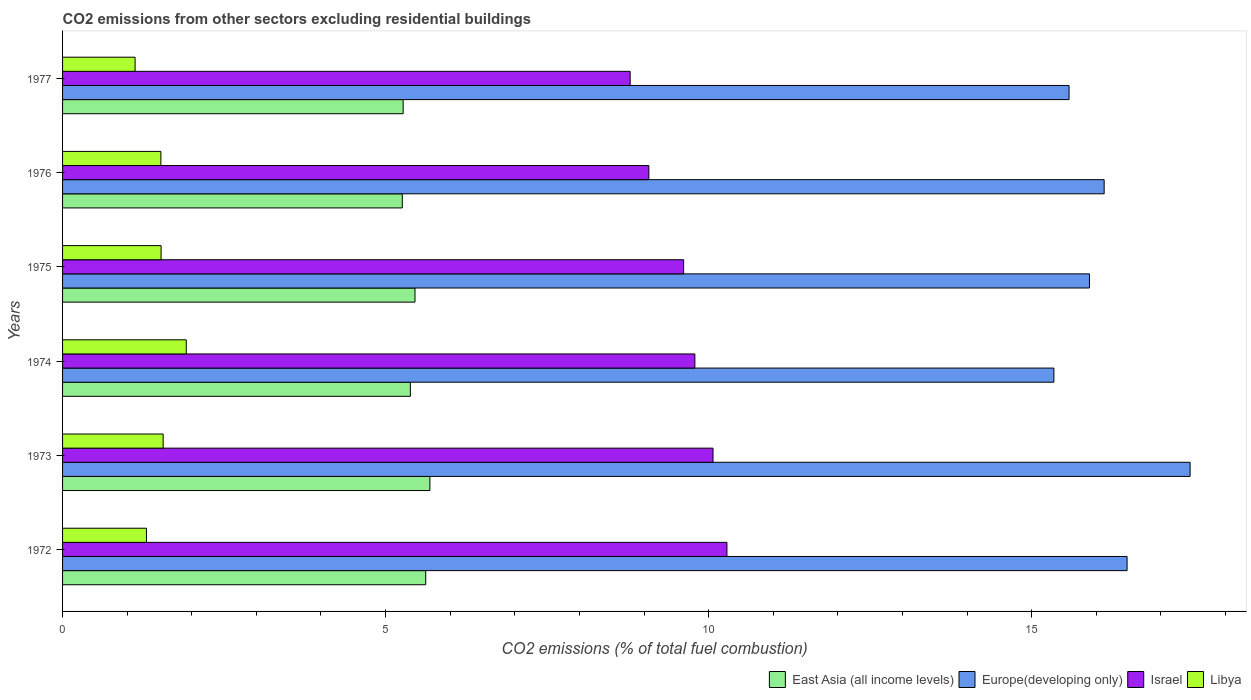Are the number of bars per tick equal to the number of legend labels?
Provide a succinct answer. Yes. In how many cases, is the number of bars for a given year not equal to the number of legend labels?
Ensure brevity in your answer.  0. What is the total CO2 emitted in Libya in 1976?
Your answer should be very brief. 1.52. Across all years, what is the maximum total CO2 emitted in Israel?
Offer a terse response. 10.28. Across all years, what is the minimum total CO2 emitted in East Asia (all income levels)?
Ensure brevity in your answer.  5.26. What is the total total CO2 emitted in Europe(developing only) in the graph?
Offer a very short reply. 96.87. What is the difference between the total CO2 emitted in Europe(developing only) in 1973 and that in 1974?
Make the answer very short. 2.11. What is the difference between the total CO2 emitted in Israel in 1975 and the total CO2 emitted in East Asia (all income levels) in 1976?
Provide a short and direct response. 4.35. What is the average total CO2 emitted in East Asia (all income levels) per year?
Make the answer very short. 5.45. In the year 1977, what is the difference between the total CO2 emitted in Europe(developing only) and total CO2 emitted in Israel?
Offer a very short reply. 6.79. In how many years, is the total CO2 emitted in Israel greater than 1 ?
Your answer should be very brief. 6. What is the ratio of the total CO2 emitted in Israel in 1972 to that in 1975?
Provide a short and direct response. 1.07. Is the total CO2 emitted in Israel in 1975 less than that in 1976?
Give a very brief answer. No. What is the difference between the highest and the second highest total CO2 emitted in Libya?
Your answer should be compact. 0.36. What is the difference between the highest and the lowest total CO2 emitted in Israel?
Keep it short and to the point. 1.5. In how many years, is the total CO2 emitted in Libya greater than the average total CO2 emitted in Libya taken over all years?
Make the answer very short. 4. Is the sum of the total CO2 emitted in Europe(developing only) in 1972 and 1975 greater than the maximum total CO2 emitted in Israel across all years?
Your response must be concise. Yes. What does the 1st bar from the top in 1977 represents?
Offer a very short reply. Libya. What does the 4th bar from the bottom in 1974 represents?
Your answer should be compact. Libya. Is it the case that in every year, the sum of the total CO2 emitted in Libya and total CO2 emitted in East Asia (all income levels) is greater than the total CO2 emitted in Israel?
Provide a short and direct response. No. How many bars are there?
Your answer should be compact. 24. Are the values on the major ticks of X-axis written in scientific E-notation?
Offer a very short reply. No. Does the graph contain any zero values?
Make the answer very short. No. Does the graph contain grids?
Keep it short and to the point. No. How many legend labels are there?
Keep it short and to the point. 4. What is the title of the graph?
Your answer should be compact. CO2 emissions from other sectors excluding residential buildings. Does "Morocco" appear as one of the legend labels in the graph?
Your response must be concise. No. What is the label or title of the X-axis?
Your answer should be compact. CO2 emissions (% of total fuel combustion). What is the label or title of the Y-axis?
Give a very brief answer. Years. What is the CO2 emissions (% of total fuel combustion) of East Asia (all income levels) in 1972?
Your answer should be very brief. 5.62. What is the CO2 emissions (% of total fuel combustion) of Europe(developing only) in 1972?
Offer a very short reply. 16.48. What is the CO2 emissions (% of total fuel combustion) in Israel in 1972?
Give a very brief answer. 10.28. What is the CO2 emissions (% of total fuel combustion) in Libya in 1972?
Offer a terse response. 1.3. What is the CO2 emissions (% of total fuel combustion) in East Asia (all income levels) in 1973?
Your answer should be compact. 5.69. What is the CO2 emissions (% of total fuel combustion) of Europe(developing only) in 1973?
Offer a very short reply. 17.45. What is the CO2 emissions (% of total fuel combustion) of Israel in 1973?
Offer a terse response. 10.07. What is the CO2 emissions (% of total fuel combustion) in Libya in 1973?
Provide a succinct answer. 1.56. What is the CO2 emissions (% of total fuel combustion) of East Asia (all income levels) in 1974?
Your answer should be very brief. 5.38. What is the CO2 emissions (% of total fuel combustion) in Europe(developing only) in 1974?
Offer a terse response. 15.34. What is the CO2 emissions (% of total fuel combustion) in Israel in 1974?
Offer a terse response. 9.79. What is the CO2 emissions (% of total fuel combustion) in Libya in 1974?
Offer a terse response. 1.91. What is the CO2 emissions (% of total fuel combustion) in East Asia (all income levels) in 1975?
Keep it short and to the point. 5.45. What is the CO2 emissions (% of total fuel combustion) in Europe(developing only) in 1975?
Offer a very short reply. 15.89. What is the CO2 emissions (% of total fuel combustion) in Israel in 1975?
Provide a succinct answer. 9.61. What is the CO2 emissions (% of total fuel combustion) in Libya in 1975?
Provide a succinct answer. 1.53. What is the CO2 emissions (% of total fuel combustion) in East Asia (all income levels) in 1976?
Offer a terse response. 5.26. What is the CO2 emissions (% of total fuel combustion) of Europe(developing only) in 1976?
Your response must be concise. 16.12. What is the CO2 emissions (% of total fuel combustion) of Israel in 1976?
Give a very brief answer. 9.07. What is the CO2 emissions (% of total fuel combustion) in Libya in 1976?
Your answer should be very brief. 1.52. What is the CO2 emissions (% of total fuel combustion) of East Asia (all income levels) in 1977?
Your response must be concise. 5.27. What is the CO2 emissions (% of total fuel combustion) of Europe(developing only) in 1977?
Give a very brief answer. 15.58. What is the CO2 emissions (% of total fuel combustion) of Israel in 1977?
Provide a succinct answer. 8.79. What is the CO2 emissions (% of total fuel combustion) of Libya in 1977?
Your answer should be compact. 1.12. Across all years, what is the maximum CO2 emissions (% of total fuel combustion) in East Asia (all income levels)?
Offer a terse response. 5.69. Across all years, what is the maximum CO2 emissions (% of total fuel combustion) of Europe(developing only)?
Keep it short and to the point. 17.45. Across all years, what is the maximum CO2 emissions (% of total fuel combustion) of Israel?
Make the answer very short. 10.28. Across all years, what is the maximum CO2 emissions (% of total fuel combustion) in Libya?
Offer a terse response. 1.91. Across all years, what is the minimum CO2 emissions (% of total fuel combustion) in East Asia (all income levels)?
Provide a succinct answer. 5.26. Across all years, what is the minimum CO2 emissions (% of total fuel combustion) of Europe(developing only)?
Your answer should be compact. 15.34. Across all years, what is the minimum CO2 emissions (% of total fuel combustion) of Israel?
Your response must be concise. 8.79. Across all years, what is the minimum CO2 emissions (% of total fuel combustion) of Libya?
Provide a succinct answer. 1.12. What is the total CO2 emissions (% of total fuel combustion) in East Asia (all income levels) in the graph?
Make the answer very short. 32.68. What is the total CO2 emissions (% of total fuel combustion) of Europe(developing only) in the graph?
Offer a terse response. 96.87. What is the total CO2 emissions (% of total fuel combustion) in Israel in the graph?
Keep it short and to the point. 57.61. What is the total CO2 emissions (% of total fuel combustion) of Libya in the graph?
Give a very brief answer. 8.94. What is the difference between the CO2 emissions (% of total fuel combustion) of East Asia (all income levels) in 1972 and that in 1973?
Provide a succinct answer. -0.06. What is the difference between the CO2 emissions (% of total fuel combustion) of Europe(developing only) in 1972 and that in 1973?
Offer a terse response. -0.98. What is the difference between the CO2 emissions (% of total fuel combustion) of Israel in 1972 and that in 1973?
Make the answer very short. 0.22. What is the difference between the CO2 emissions (% of total fuel combustion) of Libya in 1972 and that in 1973?
Provide a succinct answer. -0.26. What is the difference between the CO2 emissions (% of total fuel combustion) in East Asia (all income levels) in 1972 and that in 1974?
Provide a succinct answer. 0.24. What is the difference between the CO2 emissions (% of total fuel combustion) of Europe(developing only) in 1972 and that in 1974?
Provide a succinct answer. 1.13. What is the difference between the CO2 emissions (% of total fuel combustion) of Israel in 1972 and that in 1974?
Your response must be concise. 0.5. What is the difference between the CO2 emissions (% of total fuel combustion) of Libya in 1972 and that in 1974?
Ensure brevity in your answer.  -0.62. What is the difference between the CO2 emissions (% of total fuel combustion) in East Asia (all income levels) in 1972 and that in 1975?
Offer a very short reply. 0.17. What is the difference between the CO2 emissions (% of total fuel combustion) of Europe(developing only) in 1972 and that in 1975?
Your response must be concise. 0.58. What is the difference between the CO2 emissions (% of total fuel combustion) in Israel in 1972 and that in 1975?
Offer a very short reply. 0.67. What is the difference between the CO2 emissions (% of total fuel combustion) in Libya in 1972 and that in 1975?
Give a very brief answer. -0.23. What is the difference between the CO2 emissions (% of total fuel combustion) in East Asia (all income levels) in 1972 and that in 1976?
Keep it short and to the point. 0.36. What is the difference between the CO2 emissions (% of total fuel combustion) in Europe(developing only) in 1972 and that in 1976?
Provide a short and direct response. 0.35. What is the difference between the CO2 emissions (% of total fuel combustion) in Israel in 1972 and that in 1976?
Your response must be concise. 1.21. What is the difference between the CO2 emissions (% of total fuel combustion) in Libya in 1972 and that in 1976?
Your answer should be compact. -0.22. What is the difference between the CO2 emissions (% of total fuel combustion) in East Asia (all income levels) in 1972 and that in 1977?
Your response must be concise. 0.35. What is the difference between the CO2 emissions (% of total fuel combustion) of Europe(developing only) in 1972 and that in 1977?
Give a very brief answer. 0.9. What is the difference between the CO2 emissions (% of total fuel combustion) of Israel in 1972 and that in 1977?
Make the answer very short. 1.5. What is the difference between the CO2 emissions (% of total fuel combustion) in Libya in 1972 and that in 1977?
Your answer should be very brief. 0.18. What is the difference between the CO2 emissions (% of total fuel combustion) of East Asia (all income levels) in 1973 and that in 1974?
Give a very brief answer. 0.3. What is the difference between the CO2 emissions (% of total fuel combustion) in Europe(developing only) in 1973 and that in 1974?
Provide a short and direct response. 2.11. What is the difference between the CO2 emissions (% of total fuel combustion) of Israel in 1973 and that in 1974?
Offer a terse response. 0.28. What is the difference between the CO2 emissions (% of total fuel combustion) of Libya in 1973 and that in 1974?
Keep it short and to the point. -0.36. What is the difference between the CO2 emissions (% of total fuel combustion) of East Asia (all income levels) in 1973 and that in 1975?
Provide a short and direct response. 0.23. What is the difference between the CO2 emissions (% of total fuel combustion) of Europe(developing only) in 1973 and that in 1975?
Your response must be concise. 1.56. What is the difference between the CO2 emissions (% of total fuel combustion) in Israel in 1973 and that in 1975?
Your answer should be compact. 0.45. What is the difference between the CO2 emissions (% of total fuel combustion) in Libya in 1973 and that in 1975?
Provide a short and direct response. 0.03. What is the difference between the CO2 emissions (% of total fuel combustion) in East Asia (all income levels) in 1973 and that in 1976?
Keep it short and to the point. 0.43. What is the difference between the CO2 emissions (% of total fuel combustion) of Europe(developing only) in 1973 and that in 1976?
Make the answer very short. 1.33. What is the difference between the CO2 emissions (% of total fuel combustion) in Israel in 1973 and that in 1976?
Your response must be concise. 0.99. What is the difference between the CO2 emissions (% of total fuel combustion) in Libya in 1973 and that in 1976?
Your answer should be compact. 0.04. What is the difference between the CO2 emissions (% of total fuel combustion) in East Asia (all income levels) in 1973 and that in 1977?
Provide a succinct answer. 0.41. What is the difference between the CO2 emissions (% of total fuel combustion) of Europe(developing only) in 1973 and that in 1977?
Give a very brief answer. 1.87. What is the difference between the CO2 emissions (% of total fuel combustion) in Israel in 1973 and that in 1977?
Provide a short and direct response. 1.28. What is the difference between the CO2 emissions (% of total fuel combustion) in Libya in 1973 and that in 1977?
Offer a very short reply. 0.43. What is the difference between the CO2 emissions (% of total fuel combustion) in East Asia (all income levels) in 1974 and that in 1975?
Your answer should be very brief. -0.07. What is the difference between the CO2 emissions (% of total fuel combustion) of Europe(developing only) in 1974 and that in 1975?
Your response must be concise. -0.55. What is the difference between the CO2 emissions (% of total fuel combustion) of Israel in 1974 and that in 1975?
Provide a succinct answer. 0.17. What is the difference between the CO2 emissions (% of total fuel combustion) of Libya in 1974 and that in 1975?
Your answer should be very brief. 0.39. What is the difference between the CO2 emissions (% of total fuel combustion) in East Asia (all income levels) in 1974 and that in 1976?
Offer a terse response. 0.12. What is the difference between the CO2 emissions (% of total fuel combustion) of Europe(developing only) in 1974 and that in 1976?
Keep it short and to the point. -0.78. What is the difference between the CO2 emissions (% of total fuel combustion) in Israel in 1974 and that in 1976?
Keep it short and to the point. 0.71. What is the difference between the CO2 emissions (% of total fuel combustion) of Libya in 1974 and that in 1976?
Your answer should be very brief. 0.39. What is the difference between the CO2 emissions (% of total fuel combustion) of East Asia (all income levels) in 1974 and that in 1977?
Your response must be concise. 0.11. What is the difference between the CO2 emissions (% of total fuel combustion) of Europe(developing only) in 1974 and that in 1977?
Your answer should be compact. -0.23. What is the difference between the CO2 emissions (% of total fuel combustion) of Israel in 1974 and that in 1977?
Your answer should be very brief. 1. What is the difference between the CO2 emissions (% of total fuel combustion) of Libya in 1974 and that in 1977?
Offer a terse response. 0.79. What is the difference between the CO2 emissions (% of total fuel combustion) of East Asia (all income levels) in 1975 and that in 1976?
Keep it short and to the point. 0.2. What is the difference between the CO2 emissions (% of total fuel combustion) of Europe(developing only) in 1975 and that in 1976?
Your response must be concise. -0.23. What is the difference between the CO2 emissions (% of total fuel combustion) in Israel in 1975 and that in 1976?
Provide a succinct answer. 0.54. What is the difference between the CO2 emissions (% of total fuel combustion) of Libya in 1975 and that in 1976?
Make the answer very short. 0. What is the difference between the CO2 emissions (% of total fuel combustion) in East Asia (all income levels) in 1975 and that in 1977?
Provide a succinct answer. 0.18. What is the difference between the CO2 emissions (% of total fuel combustion) of Europe(developing only) in 1975 and that in 1977?
Ensure brevity in your answer.  0.32. What is the difference between the CO2 emissions (% of total fuel combustion) in Israel in 1975 and that in 1977?
Offer a very short reply. 0.83. What is the difference between the CO2 emissions (% of total fuel combustion) of Libya in 1975 and that in 1977?
Offer a terse response. 0.4. What is the difference between the CO2 emissions (% of total fuel combustion) of East Asia (all income levels) in 1976 and that in 1977?
Keep it short and to the point. -0.01. What is the difference between the CO2 emissions (% of total fuel combustion) in Europe(developing only) in 1976 and that in 1977?
Your answer should be very brief. 0.54. What is the difference between the CO2 emissions (% of total fuel combustion) in Israel in 1976 and that in 1977?
Your response must be concise. 0.29. What is the difference between the CO2 emissions (% of total fuel combustion) in Libya in 1976 and that in 1977?
Offer a terse response. 0.4. What is the difference between the CO2 emissions (% of total fuel combustion) of East Asia (all income levels) in 1972 and the CO2 emissions (% of total fuel combustion) of Europe(developing only) in 1973?
Your answer should be very brief. -11.83. What is the difference between the CO2 emissions (% of total fuel combustion) in East Asia (all income levels) in 1972 and the CO2 emissions (% of total fuel combustion) in Israel in 1973?
Keep it short and to the point. -4.45. What is the difference between the CO2 emissions (% of total fuel combustion) in East Asia (all income levels) in 1972 and the CO2 emissions (% of total fuel combustion) in Libya in 1973?
Make the answer very short. 4.06. What is the difference between the CO2 emissions (% of total fuel combustion) in Europe(developing only) in 1972 and the CO2 emissions (% of total fuel combustion) in Israel in 1973?
Your answer should be very brief. 6.41. What is the difference between the CO2 emissions (% of total fuel combustion) of Europe(developing only) in 1972 and the CO2 emissions (% of total fuel combustion) of Libya in 1973?
Offer a very short reply. 14.92. What is the difference between the CO2 emissions (% of total fuel combustion) in Israel in 1972 and the CO2 emissions (% of total fuel combustion) in Libya in 1973?
Keep it short and to the point. 8.73. What is the difference between the CO2 emissions (% of total fuel combustion) in East Asia (all income levels) in 1972 and the CO2 emissions (% of total fuel combustion) in Europe(developing only) in 1974?
Offer a terse response. -9.72. What is the difference between the CO2 emissions (% of total fuel combustion) in East Asia (all income levels) in 1972 and the CO2 emissions (% of total fuel combustion) in Israel in 1974?
Your response must be concise. -4.17. What is the difference between the CO2 emissions (% of total fuel combustion) of East Asia (all income levels) in 1972 and the CO2 emissions (% of total fuel combustion) of Libya in 1974?
Make the answer very short. 3.71. What is the difference between the CO2 emissions (% of total fuel combustion) of Europe(developing only) in 1972 and the CO2 emissions (% of total fuel combustion) of Israel in 1974?
Make the answer very short. 6.69. What is the difference between the CO2 emissions (% of total fuel combustion) of Europe(developing only) in 1972 and the CO2 emissions (% of total fuel combustion) of Libya in 1974?
Give a very brief answer. 14.56. What is the difference between the CO2 emissions (% of total fuel combustion) of Israel in 1972 and the CO2 emissions (% of total fuel combustion) of Libya in 1974?
Make the answer very short. 8.37. What is the difference between the CO2 emissions (% of total fuel combustion) in East Asia (all income levels) in 1972 and the CO2 emissions (% of total fuel combustion) in Europe(developing only) in 1975?
Your answer should be very brief. -10.27. What is the difference between the CO2 emissions (% of total fuel combustion) of East Asia (all income levels) in 1972 and the CO2 emissions (% of total fuel combustion) of Israel in 1975?
Your answer should be very brief. -3.99. What is the difference between the CO2 emissions (% of total fuel combustion) in East Asia (all income levels) in 1972 and the CO2 emissions (% of total fuel combustion) in Libya in 1975?
Offer a very short reply. 4.1. What is the difference between the CO2 emissions (% of total fuel combustion) in Europe(developing only) in 1972 and the CO2 emissions (% of total fuel combustion) in Israel in 1975?
Offer a terse response. 6.86. What is the difference between the CO2 emissions (% of total fuel combustion) of Europe(developing only) in 1972 and the CO2 emissions (% of total fuel combustion) of Libya in 1975?
Offer a terse response. 14.95. What is the difference between the CO2 emissions (% of total fuel combustion) in Israel in 1972 and the CO2 emissions (% of total fuel combustion) in Libya in 1975?
Offer a terse response. 8.76. What is the difference between the CO2 emissions (% of total fuel combustion) in East Asia (all income levels) in 1972 and the CO2 emissions (% of total fuel combustion) in Europe(developing only) in 1976?
Your answer should be very brief. -10.5. What is the difference between the CO2 emissions (% of total fuel combustion) in East Asia (all income levels) in 1972 and the CO2 emissions (% of total fuel combustion) in Israel in 1976?
Ensure brevity in your answer.  -3.45. What is the difference between the CO2 emissions (% of total fuel combustion) in East Asia (all income levels) in 1972 and the CO2 emissions (% of total fuel combustion) in Libya in 1976?
Make the answer very short. 4.1. What is the difference between the CO2 emissions (% of total fuel combustion) in Europe(developing only) in 1972 and the CO2 emissions (% of total fuel combustion) in Israel in 1976?
Ensure brevity in your answer.  7.4. What is the difference between the CO2 emissions (% of total fuel combustion) of Europe(developing only) in 1972 and the CO2 emissions (% of total fuel combustion) of Libya in 1976?
Your response must be concise. 14.96. What is the difference between the CO2 emissions (% of total fuel combustion) of Israel in 1972 and the CO2 emissions (% of total fuel combustion) of Libya in 1976?
Offer a terse response. 8.76. What is the difference between the CO2 emissions (% of total fuel combustion) in East Asia (all income levels) in 1972 and the CO2 emissions (% of total fuel combustion) in Europe(developing only) in 1977?
Ensure brevity in your answer.  -9.96. What is the difference between the CO2 emissions (% of total fuel combustion) in East Asia (all income levels) in 1972 and the CO2 emissions (% of total fuel combustion) in Israel in 1977?
Give a very brief answer. -3.16. What is the difference between the CO2 emissions (% of total fuel combustion) of East Asia (all income levels) in 1972 and the CO2 emissions (% of total fuel combustion) of Libya in 1977?
Give a very brief answer. 4.5. What is the difference between the CO2 emissions (% of total fuel combustion) of Europe(developing only) in 1972 and the CO2 emissions (% of total fuel combustion) of Israel in 1977?
Offer a very short reply. 7.69. What is the difference between the CO2 emissions (% of total fuel combustion) of Europe(developing only) in 1972 and the CO2 emissions (% of total fuel combustion) of Libya in 1977?
Your answer should be very brief. 15.35. What is the difference between the CO2 emissions (% of total fuel combustion) in Israel in 1972 and the CO2 emissions (% of total fuel combustion) in Libya in 1977?
Your answer should be very brief. 9.16. What is the difference between the CO2 emissions (% of total fuel combustion) in East Asia (all income levels) in 1973 and the CO2 emissions (% of total fuel combustion) in Europe(developing only) in 1974?
Offer a very short reply. -9.66. What is the difference between the CO2 emissions (% of total fuel combustion) of East Asia (all income levels) in 1973 and the CO2 emissions (% of total fuel combustion) of Israel in 1974?
Ensure brevity in your answer.  -4.1. What is the difference between the CO2 emissions (% of total fuel combustion) in East Asia (all income levels) in 1973 and the CO2 emissions (% of total fuel combustion) in Libya in 1974?
Offer a very short reply. 3.77. What is the difference between the CO2 emissions (% of total fuel combustion) of Europe(developing only) in 1973 and the CO2 emissions (% of total fuel combustion) of Israel in 1974?
Give a very brief answer. 7.67. What is the difference between the CO2 emissions (% of total fuel combustion) in Europe(developing only) in 1973 and the CO2 emissions (% of total fuel combustion) in Libya in 1974?
Keep it short and to the point. 15.54. What is the difference between the CO2 emissions (% of total fuel combustion) in Israel in 1973 and the CO2 emissions (% of total fuel combustion) in Libya in 1974?
Your answer should be very brief. 8.15. What is the difference between the CO2 emissions (% of total fuel combustion) of East Asia (all income levels) in 1973 and the CO2 emissions (% of total fuel combustion) of Europe(developing only) in 1975?
Provide a succinct answer. -10.21. What is the difference between the CO2 emissions (% of total fuel combustion) of East Asia (all income levels) in 1973 and the CO2 emissions (% of total fuel combustion) of Israel in 1975?
Make the answer very short. -3.93. What is the difference between the CO2 emissions (% of total fuel combustion) in East Asia (all income levels) in 1973 and the CO2 emissions (% of total fuel combustion) in Libya in 1975?
Your answer should be compact. 4.16. What is the difference between the CO2 emissions (% of total fuel combustion) in Europe(developing only) in 1973 and the CO2 emissions (% of total fuel combustion) in Israel in 1975?
Your response must be concise. 7.84. What is the difference between the CO2 emissions (% of total fuel combustion) in Europe(developing only) in 1973 and the CO2 emissions (% of total fuel combustion) in Libya in 1975?
Ensure brevity in your answer.  15.93. What is the difference between the CO2 emissions (% of total fuel combustion) in Israel in 1973 and the CO2 emissions (% of total fuel combustion) in Libya in 1975?
Your answer should be compact. 8.54. What is the difference between the CO2 emissions (% of total fuel combustion) of East Asia (all income levels) in 1973 and the CO2 emissions (% of total fuel combustion) of Europe(developing only) in 1976?
Ensure brevity in your answer.  -10.44. What is the difference between the CO2 emissions (% of total fuel combustion) of East Asia (all income levels) in 1973 and the CO2 emissions (% of total fuel combustion) of Israel in 1976?
Give a very brief answer. -3.39. What is the difference between the CO2 emissions (% of total fuel combustion) of East Asia (all income levels) in 1973 and the CO2 emissions (% of total fuel combustion) of Libya in 1976?
Offer a terse response. 4.16. What is the difference between the CO2 emissions (% of total fuel combustion) in Europe(developing only) in 1973 and the CO2 emissions (% of total fuel combustion) in Israel in 1976?
Give a very brief answer. 8.38. What is the difference between the CO2 emissions (% of total fuel combustion) of Europe(developing only) in 1973 and the CO2 emissions (% of total fuel combustion) of Libya in 1976?
Keep it short and to the point. 15.93. What is the difference between the CO2 emissions (% of total fuel combustion) in Israel in 1973 and the CO2 emissions (% of total fuel combustion) in Libya in 1976?
Your answer should be compact. 8.55. What is the difference between the CO2 emissions (% of total fuel combustion) in East Asia (all income levels) in 1973 and the CO2 emissions (% of total fuel combustion) in Europe(developing only) in 1977?
Your answer should be compact. -9.89. What is the difference between the CO2 emissions (% of total fuel combustion) of East Asia (all income levels) in 1973 and the CO2 emissions (% of total fuel combustion) of Israel in 1977?
Your answer should be compact. -3.1. What is the difference between the CO2 emissions (% of total fuel combustion) of East Asia (all income levels) in 1973 and the CO2 emissions (% of total fuel combustion) of Libya in 1977?
Keep it short and to the point. 4.56. What is the difference between the CO2 emissions (% of total fuel combustion) of Europe(developing only) in 1973 and the CO2 emissions (% of total fuel combustion) of Israel in 1977?
Give a very brief answer. 8.67. What is the difference between the CO2 emissions (% of total fuel combustion) in Europe(developing only) in 1973 and the CO2 emissions (% of total fuel combustion) in Libya in 1977?
Offer a very short reply. 16.33. What is the difference between the CO2 emissions (% of total fuel combustion) in Israel in 1973 and the CO2 emissions (% of total fuel combustion) in Libya in 1977?
Your answer should be very brief. 8.95. What is the difference between the CO2 emissions (% of total fuel combustion) of East Asia (all income levels) in 1974 and the CO2 emissions (% of total fuel combustion) of Europe(developing only) in 1975?
Provide a succinct answer. -10.51. What is the difference between the CO2 emissions (% of total fuel combustion) of East Asia (all income levels) in 1974 and the CO2 emissions (% of total fuel combustion) of Israel in 1975?
Give a very brief answer. -4.23. What is the difference between the CO2 emissions (% of total fuel combustion) in East Asia (all income levels) in 1974 and the CO2 emissions (% of total fuel combustion) in Libya in 1975?
Give a very brief answer. 3.86. What is the difference between the CO2 emissions (% of total fuel combustion) of Europe(developing only) in 1974 and the CO2 emissions (% of total fuel combustion) of Israel in 1975?
Give a very brief answer. 5.73. What is the difference between the CO2 emissions (% of total fuel combustion) of Europe(developing only) in 1974 and the CO2 emissions (% of total fuel combustion) of Libya in 1975?
Your answer should be very brief. 13.82. What is the difference between the CO2 emissions (% of total fuel combustion) of Israel in 1974 and the CO2 emissions (% of total fuel combustion) of Libya in 1975?
Your answer should be very brief. 8.26. What is the difference between the CO2 emissions (% of total fuel combustion) of East Asia (all income levels) in 1974 and the CO2 emissions (% of total fuel combustion) of Europe(developing only) in 1976?
Your response must be concise. -10.74. What is the difference between the CO2 emissions (% of total fuel combustion) in East Asia (all income levels) in 1974 and the CO2 emissions (% of total fuel combustion) in Israel in 1976?
Give a very brief answer. -3.69. What is the difference between the CO2 emissions (% of total fuel combustion) of East Asia (all income levels) in 1974 and the CO2 emissions (% of total fuel combustion) of Libya in 1976?
Provide a succinct answer. 3.86. What is the difference between the CO2 emissions (% of total fuel combustion) in Europe(developing only) in 1974 and the CO2 emissions (% of total fuel combustion) in Israel in 1976?
Provide a short and direct response. 6.27. What is the difference between the CO2 emissions (% of total fuel combustion) in Europe(developing only) in 1974 and the CO2 emissions (% of total fuel combustion) in Libya in 1976?
Ensure brevity in your answer.  13.82. What is the difference between the CO2 emissions (% of total fuel combustion) of Israel in 1974 and the CO2 emissions (% of total fuel combustion) of Libya in 1976?
Provide a succinct answer. 8.27. What is the difference between the CO2 emissions (% of total fuel combustion) in East Asia (all income levels) in 1974 and the CO2 emissions (% of total fuel combustion) in Europe(developing only) in 1977?
Your response must be concise. -10.2. What is the difference between the CO2 emissions (% of total fuel combustion) of East Asia (all income levels) in 1974 and the CO2 emissions (% of total fuel combustion) of Israel in 1977?
Provide a succinct answer. -3.4. What is the difference between the CO2 emissions (% of total fuel combustion) in East Asia (all income levels) in 1974 and the CO2 emissions (% of total fuel combustion) in Libya in 1977?
Ensure brevity in your answer.  4.26. What is the difference between the CO2 emissions (% of total fuel combustion) in Europe(developing only) in 1974 and the CO2 emissions (% of total fuel combustion) in Israel in 1977?
Offer a terse response. 6.56. What is the difference between the CO2 emissions (% of total fuel combustion) in Europe(developing only) in 1974 and the CO2 emissions (% of total fuel combustion) in Libya in 1977?
Provide a short and direct response. 14.22. What is the difference between the CO2 emissions (% of total fuel combustion) of Israel in 1974 and the CO2 emissions (% of total fuel combustion) of Libya in 1977?
Offer a very short reply. 8.66. What is the difference between the CO2 emissions (% of total fuel combustion) in East Asia (all income levels) in 1975 and the CO2 emissions (% of total fuel combustion) in Europe(developing only) in 1976?
Ensure brevity in your answer.  -10.67. What is the difference between the CO2 emissions (% of total fuel combustion) of East Asia (all income levels) in 1975 and the CO2 emissions (% of total fuel combustion) of Israel in 1976?
Your answer should be compact. -3.62. What is the difference between the CO2 emissions (% of total fuel combustion) of East Asia (all income levels) in 1975 and the CO2 emissions (% of total fuel combustion) of Libya in 1976?
Keep it short and to the point. 3.93. What is the difference between the CO2 emissions (% of total fuel combustion) of Europe(developing only) in 1975 and the CO2 emissions (% of total fuel combustion) of Israel in 1976?
Your answer should be compact. 6.82. What is the difference between the CO2 emissions (% of total fuel combustion) of Europe(developing only) in 1975 and the CO2 emissions (% of total fuel combustion) of Libya in 1976?
Provide a succinct answer. 14.37. What is the difference between the CO2 emissions (% of total fuel combustion) of Israel in 1975 and the CO2 emissions (% of total fuel combustion) of Libya in 1976?
Ensure brevity in your answer.  8.09. What is the difference between the CO2 emissions (% of total fuel combustion) in East Asia (all income levels) in 1975 and the CO2 emissions (% of total fuel combustion) in Europe(developing only) in 1977?
Offer a terse response. -10.12. What is the difference between the CO2 emissions (% of total fuel combustion) of East Asia (all income levels) in 1975 and the CO2 emissions (% of total fuel combustion) of Israel in 1977?
Your answer should be compact. -3.33. What is the difference between the CO2 emissions (% of total fuel combustion) of East Asia (all income levels) in 1975 and the CO2 emissions (% of total fuel combustion) of Libya in 1977?
Offer a terse response. 4.33. What is the difference between the CO2 emissions (% of total fuel combustion) in Europe(developing only) in 1975 and the CO2 emissions (% of total fuel combustion) in Israel in 1977?
Your answer should be very brief. 7.11. What is the difference between the CO2 emissions (% of total fuel combustion) in Europe(developing only) in 1975 and the CO2 emissions (% of total fuel combustion) in Libya in 1977?
Give a very brief answer. 14.77. What is the difference between the CO2 emissions (% of total fuel combustion) of Israel in 1975 and the CO2 emissions (% of total fuel combustion) of Libya in 1977?
Your answer should be compact. 8.49. What is the difference between the CO2 emissions (% of total fuel combustion) in East Asia (all income levels) in 1976 and the CO2 emissions (% of total fuel combustion) in Europe(developing only) in 1977?
Offer a terse response. -10.32. What is the difference between the CO2 emissions (% of total fuel combustion) of East Asia (all income levels) in 1976 and the CO2 emissions (% of total fuel combustion) of Israel in 1977?
Provide a short and direct response. -3.53. What is the difference between the CO2 emissions (% of total fuel combustion) of East Asia (all income levels) in 1976 and the CO2 emissions (% of total fuel combustion) of Libya in 1977?
Your answer should be very brief. 4.14. What is the difference between the CO2 emissions (% of total fuel combustion) in Europe(developing only) in 1976 and the CO2 emissions (% of total fuel combustion) in Israel in 1977?
Provide a succinct answer. 7.34. What is the difference between the CO2 emissions (% of total fuel combustion) of Europe(developing only) in 1976 and the CO2 emissions (% of total fuel combustion) of Libya in 1977?
Provide a short and direct response. 15. What is the difference between the CO2 emissions (% of total fuel combustion) of Israel in 1976 and the CO2 emissions (% of total fuel combustion) of Libya in 1977?
Offer a very short reply. 7.95. What is the average CO2 emissions (% of total fuel combustion) in East Asia (all income levels) per year?
Your response must be concise. 5.45. What is the average CO2 emissions (% of total fuel combustion) in Europe(developing only) per year?
Keep it short and to the point. 16.14. What is the average CO2 emissions (% of total fuel combustion) in Israel per year?
Ensure brevity in your answer.  9.6. What is the average CO2 emissions (% of total fuel combustion) of Libya per year?
Your answer should be compact. 1.49. In the year 1972, what is the difference between the CO2 emissions (% of total fuel combustion) in East Asia (all income levels) and CO2 emissions (% of total fuel combustion) in Europe(developing only)?
Provide a succinct answer. -10.86. In the year 1972, what is the difference between the CO2 emissions (% of total fuel combustion) in East Asia (all income levels) and CO2 emissions (% of total fuel combustion) in Israel?
Your answer should be compact. -4.66. In the year 1972, what is the difference between the CO2 emissions (% of total fuel combustion) of East Asia (all income levels) and CO2 emissions (% of total fuel combustion) of Libya?
Your answer should be very brief. 4.32. In the year 1972, what is the difference between the CO2 emissions (% of total fuel combustion) of Europe(developing only) and CO2 emissions (% of total fuel combustion) of Israel?
Your response must be concise. 6.19. In the year 1972, what is the difference between the CO2 emissions (% of total fuel combustion) of Europe(developing only) and CO2 emissions (% of total fuel combustion) of Libya?
Provide a short and direct response. 15.18. In the year 1972, what is the difference between the CO2 emissions (% of total fuel combustion) of Israel and CO2 emissions (% of total fuel combustion) of Libya?
Ensure brevity in your answer.  8.98. In the year 1973, what is the difference between the CO2 emissions (% of total fuel combustion) of East Asia (all income levels) and CO2 emissions (% of total fuel combustion) of Europe(developing only)?
Give a very brief answer. -11.77. In the year 1973, what is the difference between the CO2 emissions (% of total fuel combustion) of East Asia (all income levels) and CO2 emissions (% of total fuel combustion) of Israel?
Give a very brief answer. -4.38. In the year 1973, what is the difference between the CO2 emissions (% of total fuel combustion) in East Asia (all income levels) and CO2 emissions (% of total fuel combustion) in Libya?
Ensure brevity in your answer.  4.13. In the year 1973, what is the difference between the CO2 emissions (% of total fuel combustion) in Europe(developing only) and CO2 emissions (% of total fuel combustion) in Israel?
Your answer should be very brief. 7.38. In the year 1973, what is the difference between the CO2 emissions (% of total fuel combustion) of Europe(developing only) and CO2 emissions (% of total fuel combustion) of Libya?
Provide a succinct answer. 15.9. In the year 1973, what is the difference between the CO2 emissions (% of total fuel combustion) in Israel and CO2 emissions (% of total fuel combustion) in Libya?
Offer a very short reply. 8.51. In the year 1974, what is the difference between the CO2 emissions (% of total fuel combustion) of East Asia (all income levels) and CO2 emissions (% of total fuel combustion) of Europe(developing only)?
Provide a short and direct response. -9.96. In the year 1974, what is the difference between the CO2 emissions (% of total fuel combustion) in East Asia (all income levels) and CO2 emissions (% of total fuel combustion) in Israel?
Offer a terse response. -4.4. In the year 1974, what is the difference between the CO2 emissions (% of total fuel combustion) of East Asia (all income levels) and CO2 emissions (% of total fuel combustion) of Libya?
Your response must be concise. 3.47. In the year 1974, what is the difference between the CO2 emissions (% of total fuel combustion) of Europe(developing only) and CO2 emissions (% of total fuel combustion) of Israel?
Offer a very short reply. 5.56. In the year 1974, what is the difference between the CO2 emissions (% of total fuel combustion) in Europe(developing only) and CO2 emissions (% of total fuel combustion) in Libya?
Provide a short and direct response. 13.43. In the year 1974, what is the difference between the CO2 emissions (% of total fuel combustion) in Israel and CO2 emissions (% of total fuel combustion) in Libya?
Ensure brevity in your answer.  7.87. In the year 1975, what is the difference between the CO2 emissions (% of total fuel combustion) of East Asia (all income levels) and CO2 emissions (% of total fuel combustion) of Europe(developing only)?
Offer a terse response. -10.44. In the year 1975, what is the difference between the CO2 emissions (% of total fuel combustion) in East Asia (all income levels) and CO2 emissions (% of total fuel combustion) in Israel?
Ensure brevity in your answer.  -4.16. In the year 1975, what is the difference between the CO2 emissions (% of total fuel combustion) of East Asia (all income levels) and CO2 emissions (% of total fuel combustion) of Libya?
Your response must be concise. 3.93. In the year 1975, what is the difference between the CO2 emissions (% of total fuel combustion) of Europe(developing only) and CO2 emissions (% of total fuel combustion) of Israel?
Provide a succinct answer. 6.28. In the year 1975, what is the difference between the CO2 emissions (% of total fuel combustion) of Europe(developing only) and CO2 emissions (% of total fuel combustion) of Libya?
Offer a terse response. 14.37. In the year 1975, what is the difference between the CO2 emissions (% of total fuel combustion) in Israel and CO2 emissions (% of total fuel combustion) in Libya?
Your response must be concise. 8.09. In the year 1976, what is the difference between the CO2 emissions (% of total fuel combustion) in East Asia (all income levels) and CO2 emissions (% of total fuel combustion) in Europe(developing only)?
Offer a very short reply. -10.86. In the year 1976, what is the difference between the CO2 emissions (% of total fuel combustion) in East Asia (all income levels) and CO2 emissions (% of total fuel combustion) in Israel?
Provide a short and direct response. -3.82. In the year 1976, what is the difference between the CO2 emissions (% of total fuel combustion) of East Asia (all income levels) and CO2 emissions (% of total fuel combustion) of Libya?
Offer a terse response. 3.74. In the year 1976, what is the difference between the CO2 emissions (% of total fuel combustion) in Europe(developing only) and CO2 emissions (% of total fuel combustion) in Israel?
Your answer should be very brief. 7.05. In the year 1976, what is the difference between the CO2 emissions (% of total fuel combustion) in Europe(developing only) and CO2 emissions (% of total fuel combustion) in Libya?
Keep it short and to the point. 14.6. In the year 1976, what is the difference between the CO2 emissions (% of total fuel combustion) in Israel and CO2 emissions (% of total fuel combustion) in Libya?
Give a very brief answer. 7.55. In the year 1977, what is the difference between the CO2 emissions (% of total fuel combustion) in East Asia (all income levels) and CO2 emissions (% of total fuel combustion) in Europe(developing only)?
Offer a terse response. -10.31. In the year 1977, what is the difference between the CO2 emissions (% of total fuel combustion) in East Asia (all income levels) and CO2 emissions (% of total fuel combustion) in Israel?
Keep it short and to the point. -3.51. In the year 1977, what is the difference between the CO2 emissions (% of total fuel combustion) of East Asia (all income levels) and CO2 emissions (% of total fuel combustion) of Libya?
Provide a succinct answer. 4.15. In the year 1977, what is the difference between the CO2 emissions (% of total fuel combustion) in Europe(developing only) and CO2 emissions (% of total fuel combustion) in Israel?
Offer a very short reply. 6.79. In the year 1977, what is the difference between the CO2 emissions (% of total fuel combustion) of Europe(developing only) and CO2 emissions (% of total fuel combustion) of Libya?
Keep it short and to the point. 14.46. In the year 1977, what is the difference between the CO2 emissions (% of total fuel combustion) of Israel and CO2 emissions (% of total fuel combustion) of Libya?
Make the answer very short. 7.66. What is the ratio of the CO2 emissions (% of total fuel combustion) of East Asia (all income levels) in 1972 to that in 1973?
Your response must be concise. 0.99. What is the ratio of the CO2 emissions (% of total fuel combustion) in Europe(developing only) in 1972 to that in 1973?
Give a very brief answer. 0.94. What is the ratio of the CO2 emissions (% of total fuel combustion) of Israel in 1972 to that in 1973?
Offer a terse response. 1.02. What is the ratio of the CO2 emissions (% of total fuel combustion) in Libya in 1972 to that in 1973?
Your answer should be compact. 0.83. What is the ratio of the CO2 emissions (% of total fuel combustion) in East Asia (all income levels) in 1972 to that in 1974?
Make the answer very short. 1.04. What is the ratio of the CO2 emissions (% of total fuel combustion) of Europe(developing only) in 1972 to that in 1974?
Provide a succinct answer. 1.07. What is the ratio of the CO2 emissions (% of total fuel combustion) in Israel in 1972 to that in 1974?
Your answer should be very brief. 1.05. What is the ratio of the CO2 emissions (% of total fuel combustion) of Libya in 1972 to that in 1974?
Provide a succinct answer. 0.68. What is the ratio of the CO2 emissions (% of total fuel combustion) of East Asia (all income levels) in 1972 to that in 1975?
Provide a short and direct response. 1.03. What is the ratio of the CO2 emissions (% of total fuel combustion) in Europe(developing only) in 1972 to that in 1975?
Provide a short and direct response. 1.04. What is the ratio of the CO2 emissions (% of total fuel combustion) of Israel in 1972 to that in 1975?
Provide a short and direct response. 1.07. What is the ratio of the CO2 emissions (% of total fuel combustion) in Libya in 1972 to that in 1975?
Your answer should be compact. 0.85. What is the ratio of the CO2 emissions (% of total fuel combustion) in East Asia (all income levels) in 1972 to that in 1976?
Provide a succinct answer. 1.07. What is the ratio of the CO2 emissions (% of total fuel combustion) of Europe(developing only) in 1972 to that in 1976?
Your answer should be compact. 1.02. What is the ratio of the CO2 emissions (% of total fuel combustion) in Israel in 1972 to that in 1976?
Offer a very short reply. 1.13. What is the ratio of the CO2 emissions (% of total fuel combustion) of Libya in 1972 to that in 1976?
Give a very brief answer. 0.85. What is the ratio of the CO2 emissions (% of total fuel combustion) of East Asia (all income levels) in 1972 to that in 1977?
Make the answer very short. 1.07. What is the ratio of the CO2 emissions (% of total fuel combustion) in Europe(developing only) in 1972 to that in 1977?
Keep it short and to the point. 1.06. What is the ratio of the CO2 emissions (% of total fuel combustion) in Israel in 1972 to that in 1977?
Provide a short and direct response. 1.17. What is the ratio of the CO2 emissions (% of total fuel combustion) in Libya in 1972 to that in 1977?
Provide a short and direct response. 1.16. What is the ratio of the CO2 emissions (% of total fuel combustion) of East Asia (all income levels) in 1973 to that in 1974?
Ensure brevity in your answer.  1.06. What is the ratio of the CO2 emissions (% of total fuel combustion) in Europe(developing only) in 1973 to that in 1974?
Your response must be concise. 1.14. What is the ratio of the CO2 emissions (% of total fuel combustion) in Israel in 1973 to that in 1974?
Ensure brevity in your answer.  1.03. What is the ratio of the CO2 emissions (% of total fuel combustion) of Libya in 1973 to that in 1974?
Make the answer very short. 0.81. What is the ratio of the CO2 emissions (% of total fuel combustion) of East Asia (all income levels) in 1973 to that in 1975?
Your answer should be very brief. 1.04. What is the ratio of the CO2 emissions (% of total fuel combustion) of Europe(developing only) in 1973 to that in 1975?
Ensure brevity in your answer.  1.1. What is the ratio of the CO2 emissions (% of total fuel combustion) in Israel in 1973 to that in 1975?
Your answer should be very brief. 1.05. What is the ratio of the CO2 emissions (% of total fuel combustion) of Libya in 1973 to that in 1975?
Give a very brief answer. 1.02. What is the ratio of the CO2 emissions (% of total fuel combustion) in East Asia (all income levels) in 1973 to that in 1976?
Give a very brief answer. 1.08. What is the ratio of the CO2 emissions (% of total fuel combustion) of Europe(developing only) in 1973 to that in 1976?
Offer a terse response. 1.08. What is the ratio of the CO2 emissions (% of total fuel combustion) of Israel in 1973 to that in 1976?
Your answer should be compact. 1.11. What is the ratio of the CO2 emissions (% of total fuel combustion) of Libya in 1973 to that in 1976?
Offer a terse response. 1.02. What is the ratio of the CO2 emissions (% of total fuel combustion) of East Asia (all income levels) in 1973 to that in 1977?
Provide a succinct answer. 1.08. What is the ratio of the CO2 emissions (% of total fuel combustion) of Europe(developing only) in 1973 to that in 1977?
Provide a short and direct response. 1.12. What is the ratio of the CO2 emissions (% of total fuel combustion) in Israel in 1973 to that in 1977?
Provide a succinct answer. 1.15. What is the ratio of the CO2 emissions (% of total fuel combustion) in Libya in 1973 to that in 1977?
Make the answer very short. 1.39. What is the ratio of the CO2 emissions (% of total fuel combustion) of East Asia (all income levels) in 1974 to that in 1975?
Provide a succinct answer. 0.99. What is the ratio of the CO2 emissions (% of total fuel combustion) of Europe(developing only) in 1974 to that in 1975?
Give a very brief answer. 0.97. What is the ratio of the CO2 emissions (% of total fuel combustion) of Israel in 1974 to that in 1975?
Provide a succinct answer. 1.02. What is the ratio of the CO2 emissions (% of total fuel combustion) in Libya in 1974 to that in 1975?
Keep it short and to the point. 1.26. What is the ratio of the CO2 emissions (% of total fuel combustion) of East Asia (all income levels) in 1974 to that in 1976?
Your answer should be compact. 1.02. What is the ratio of the CO2 emissions (% of total fuel combustion) in Europe(developing only) in 1974 to that in 1976?
Your answer should be very brief. 0.95. What is the ratio of the CO2 emissions (% of total fuel combustion) in Israel in 1974 to that in 1976?
Your answer should be very brief. 1.08. What is the ratio of the CO2 emissions (% of total fuel combustion) in Libya in 1974 to that in 1976?
Give a very brief answer. 1.26. What is the ratio of the CO2 emissions (% of total fuel combustion) of East Asia (all income levels) in 1974 to that in 1977?
Provide a succinct answer. 1.02. What is the ratio of the CO2 emissions (% of total fuel combustion) in Europe(developing only) in 1974 to that in 1977?
Provide a succinct answer. 0.98. What is the ratio of the CO2 emissions (% of total fuel combustion) in Israel in 1974 to that in 1977?
Your answer should be very brief. 1.11. What is the ratio of the CO2 emissions (% of total fuel combustion) of Libya in 1974 to that in 1977?
Make the answer very short. 1.71. What is the ratio of the CO2 emissions (% of total fuel combustion) of East Asia (all income levels) in 1975 to that in 1976?
Your answer should be compact. 1.04. What is the ratio of the CO2 emissions (% of total fuel combustion) of Europe(developing only) in 1975 to that in 1976?
Your answer should be very brief. 0.99. What is the ratio of the CO2 emissions (% of total fuel combustion) in Israel in 1975 to that in 1976?
Provide a short and direct response. 1.06. What is the ratio of the CO2 emissions (% of total fuel combustion) in East Asia (all income levels) in 1975 to that in 1977?
Offer a very short reply. 1.03. What is the ratio of the CO2 emissions (% of total fuel combustion) of Europe(developing only) in 1975 to that in 1977?
Keep it short and to the point. 1.02. What is the ratio of the CO2 emissions (% of total fuel combustion) of Israel in 1975 to that in 1977?
Make the answer very short. 1.09. What is the ratio of the CO2 emissions (% of total fuel combustion) in Libya in 1975 to that in 1977?
Keep it short and to the point. 1.36. What is the ratio of the CO2 emissions (% of total fuel combustion) in Europe(developing only) in 1976 to that in 1977?
Make the answer very short. 1.03. What is the ratio of the CO2 emissions (% of total fuel combustion) in Israel in 1976 to that in 1977?
Your answer should be very brief. 1.03. What is the ratio of the CO2 emissions (% of total fuel combustion) of Libya in 1976 to that in 1977?
Provide a short and direct response. 1.36. What is the difference between the highest and the second highest CO2 emissions (% of total fuel combustion) in East Asia (all income levels)?
Your answer should be very brief. 0.06. What is the difference between the highest and the second highest CO2 emissions (% of total fuel combustion) of Europe(developing only)?
Your answer should be very brief. 0.98. What is the difference between the highest and the second highest CO2 emissions (% of total fuel combustion) of Israel?
Give a very brief answer. 0.22. What is the difference between the highest and the second highest CO2 emissions (% of total fuel combustion) in Libya?
Make the answer very short. 0.36. What is the difference between the highest and the lowest CO2 emissions (% of total fuel combustion) in East Asia (all income levels)?
Keep it short and to the point. 0.43. What is the difference between the highest and the lowest CO2 emissions (% of total fuel combustion) in Europe(developing only)?
Provide a short and direct response. 2.11. What is the difference between the highest and the lowest CO2 emissions (% of total fuel combustion) in Israel?
Your answer should be compact. 1.5. What is the difference between the highest and the lowest CO2 emissions (% of total fuel combustion) of Libya?
Provide a succinct answer. 0.79. 